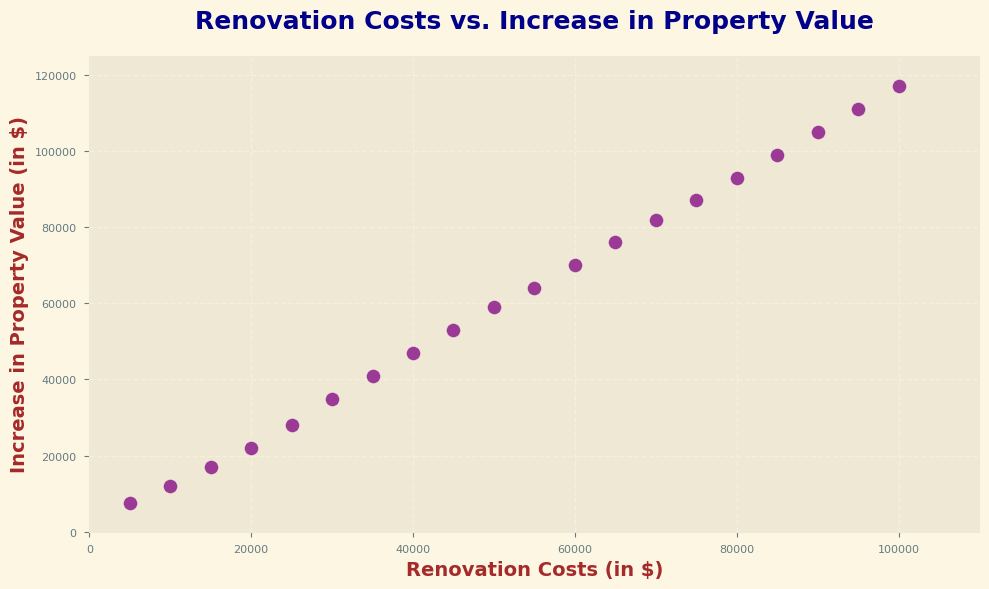What's the median increase in property value for renovations costing between $30,000 and $50,000? First, identify the renovation costs within $30,000 to $50,000: ($30,000, $35,000, $40,000, $45,000, $50,000). Corresponding increases in property value are ($35,000, $41,000, $47,000, $53,000, $59,000). To find the median, list these values in order and pick the middle one: $47,000.
Answer: $47,000 Which renovation cost corresponds to the highest increase in property value? Look at the y-axis values and find the highest point, which is $117,000. The corresponding x-axis (renovation cost) is $100,000.
Answer: $100,000 Is there a stronger increase in property value for renovations costing $50,000 or $20,000? Compare the increase corresponding to $50,000 and $20,000. A $50,000 renovation results in a $59,000 increase, while a $20,000 renovation results in a $22,000 increase. So $50,000 has a stronger increase.
Answer: $50,000 What is the average increase in property value for renovations costing $70,000, $80,000, and $90,000? Identify the increases for these renovation costs: ($82,000, $93,000, $105,000). Sum them up: $82,000 + $93,000 + $105,000 = $280,000. Divide by 3 for the average: $280,000 / 3 = $93,333.33.
Answer: $93,333.33 How much does the property value increase on average for every $10,000 spent on renovation, considering the data points? Total increase in property value across all points is the highest value, $117,000. The total renovation cost is $100,000. Average increase per $10,000 = ($117,000 / 100,000) * 10,000 = $11,700.
Answer: $11,700 What is the increase in property value when the renovation cost is doubled from $25,000 to $50,000? Increase in property value for $25,000 is $28,000 and for $50,000 is $59,000. The difference = $59,000 - $28,000 = $31,000. So, doubling to $50,000 results in a $31,000 additional increase.
Answer: $31,000 Which renovation cost marks the threshold where increase in property value first exceeds $50,000? Look for the smallest renovation cost with a corresponding increase over $50,000. It occurs at $40,000 since the increase is $53,000.
Answer: $40,000 How much more does the property value increase for a $100,000 renovation compared to a $60,000 renovation? Increase for $100,000 is $117,000, and for $60,000 is $70,000. The difference is $117,000 - $70,000 = $47,000.
Answer: $47,000 